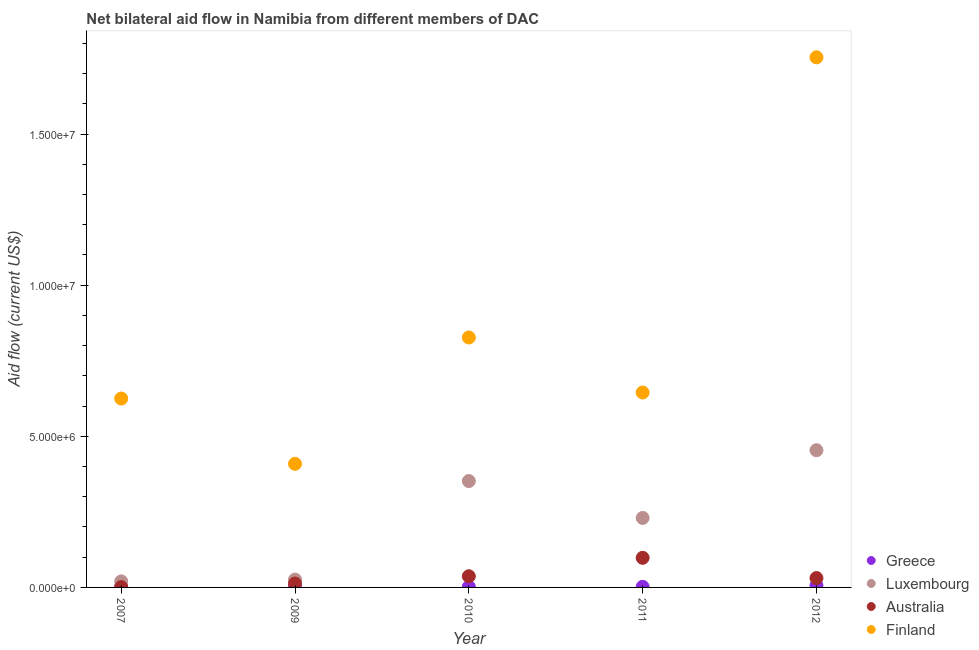How many different coloured dotlines are there?
Offer a terse response. 4. What is the amount of aid given by australia in 2009?
Provide a short and direct response. 1.30e+05. Across all years, what is the maximum amount of aid given by luxembourg?
Your answer should be compact. 4.54e+06. Across all years, what is the minimum amount of aid given by finland?
Your answer should be very brief. 4.09e+06. What is the total amount of aid given by greece in the graph?
Your answer should be compact. 1.30e+05. What is the difference between the amount of aid given by greece in 2010 and that in 2012?
Your answer should be compact. -4.00e+04. What is the difference between the amount of aid given by greece in 2010 and the amount of aid given by luxembourg in 2009?
Make the answer very short. -2.40e+05. What is the average amount of aid given by greece per year?
Provide a short and direct response. 2.60e+04. In the year 2007, what is the difference between the amount of aid given by australia and amount of aid given by finland?
Your response must be concise. -6.24e+06. In how many years, is the amount of aid given by greece greater than 7000000 US$?
Ensure brevity in your answer.  0. What is the ratio of the amount of aid given by australia in 2007 to that in 2012?
Your response must be concise. 0.03. Is the difference between the amount of aid given by greece in 2010 and 2012 greater than the difference between the amount of aid given by australia in 2010 and 2012?
Ensure brevity in your answer.  No. What is the difference between the highest and the lowest amount of aid given by finland?
Give a very brief answer. 1.34e+07. Is the sum of the amount of aid given by luxembourg in 2007 and 2009 greater than the maximum amount of aid given by finland across all years?
Keep it short and to the point. No. Is it the case that in every year, the sum of the amount of aid given by greece and amount of aid given by luxembourg is greater than the sum of amount of aid given by finland and amount of aid given by australia?
Give a very brief answer. No. Is the amount of aid given by australia strictly greater than the amount of aid given by finland over the years?
Give a very brief answer. No. How many dotlines are there?
Ensure brevity in your answer.  4. How many years are there in the graph?
Your response must be concise. 5. How are the legend labels stacked?
Provide a short and direct response. Vertical. What is the title of the graph?
Offer a very short reply. Net bilateral aid flow in Namibia from different members of DAC. Does "Tertiary schools" appear as one of the legend labels in the graph?
Your response must be concise. No. What is the label or title of the X-axis?
Your response must be concise. Year. What is the Aid flow (current US$) of Greece in 2007?
Your response must be concise. 10000. What is the Aid flow (current US$) in Australia in 2007?
Make the answer very short. 10000. What is the Aid flow (current US$) in Finland in 2007?
Your response must be concise. 6.25e+06. What is the Aid flow (current US$) of Luxembourg in 2009?
Give a very brief answer. 2.60e+05. What is the Aid flow (current US$) in Finland in 2009?
Give a very brief answer. 4.09e+06. What is the Aid flow (current US$) in Greece in 2010?
Offer a very short reply. 2.00e+04. What is the Aid flow (current US$) in Luxembourg in 2010?
Give a very brief answer. 3.52e+06. What is the Aid flow (current US$) in Finland in 2010?
Your response must be concise. 8.27e+06. What is the Aid flow (current US$) in Luxembourg in 2011?
Provide a succinct answer. 2.30e+06. What is the Aid flow (current US$) in Australia in 2011?
Your response must be concise. 9.80e+05. What is the Aid flow (current US$) of Finland in 2011?
Give a very brief answer. 6.45e+06. What is the Aid flow (current US$) in Luxembourg in 2012?
Your answer should be very brief. 4.54e+06. What is the Aid flow (current US$) of Finland in 2012?
Provide a short and direct response. 1.75e+07. Across all years, what is the maximum Aid flow (current US$) of Greece?
Provide a succinct answer. 6.00e+04. Across all years, what is the maximum Aid flow (current US$) in Luxembourg?
Give a very brief answer. 4.54e+06. Across all years, what is the maximum Aid flow (current US$) of Australia?
Offer a very short reply. 9.80e+05. Across all years, what is the maximum Aid flow (current US$) of Finland?
Give a very brief answer. 1.75e+07. Across all years, what is the minimum Aid flow (current US$) in Greece?
Make the answer very short. 10000. Across all years, what is the minimum Aid flow (current US$) in Luxembourg?
Ensure brevity in your answer.  2.00e+05. Across all years, what is the minimum Aid flow (current US$) in Finland?
Make the answer very short. 4.09e+06. What is the total Aid flow (current US$) in Greece in the graph?
Give a very brief answer. 1.30e+05. What is the total Aid flow (current US$) of Luxembourg in the graph?
Provide a short and direct response. 1.08e+07. What is the total Aid flow (current US$) of Australia in the graph?
Offer a very short reply. 1.80e+06. What is the total Aid flow (current US$) in Finland in the graph?
Your answer should be very brief. 4.26e+07. What is the difference between the Aid flow (current US$) in Greece in 2007 and that in 2009?
Offer a very short reply. -10000. What is the difference between the Aid flow (current US$) in Luxembourg in 2007 and that in 2009?
Provide a short and direct response. -6.00e+04. What is the difference between the Aid flow (current US$) in Australia in 2007 and that in 2009?
Your response must be concise. -1.20e+05. What is the difference between the Aid flow (current US$) of Finland in 2007 and that in 2009?
Ensure brevity in your answer.  2.16e+06. What is the difference between the Aid flow (current US$) of Greece in 2007 and that in 2010?
Provide a succinct answer. -10000. What is the difference between the Aid flow (current US$) in Luxembourg in 2007 and that in 2010?
Your answer should be compact. -3.32e+06. What is the difference between the Aid flow (current US$) in Australia in 2007 and that in 2010?
Provide a short and direct response. -3.60e+05. What is the difference between the Aid flow (current US$) in Finland in 2007 and that in 2010?
Provide a succinct answer. -2.02e+06. What is the difference between the Aid flow (current US$) of Greece in 2007 and that in 2011?
Your response must be concise. -10000. What is the difference between the Aid flow (current US$) in Luxembourg in 2007 and that in 2011?
Your answer should be compact. -2.10e+06. What is the difference between the Aid flow (current US$) of Australia in 2007 and that in 2011?
Your answer should be compact. -9.70e+05. What is the difference between the Aid flow (current US$) of Luxembourg in 2007 and that in 2012?
Your response must be concise. -4.34e+06. What is the difference between the Aid flow (current US$) of Australia in 2007 and that in 2012?
Give a very brief answer. -3.00e+05. What is the difference between the Aid flow (current US$) of Finland in 2007 and that in 2012?
Make the answer very short. -1.13e+07. What is the difference between the Aid flow (current US$) of Greece in 2009 and that in 2010?
Your answer should be very brief. 0. What is the difference between the Aid flow (current US$) of Luxembourg in 2009 and that in 2010?
Keep it short and to the point. -3.26e+06. What is the difference between the Aid flow (current US$) of Australia in 2009 and that in 2010?
Your response must be concise. -2.40e+05. What is the difference between the Aid flow (current US$) of Finland in 2009 and that in 2010?
Keep it short and to the point. -4.18e+06. What is the difference between the Aid flow (current US$) in Greece in 2009 and that in 2011?
Ensure brevity in your answer.  0. What is the difference between the Aid flow (current US$) in Luxembourg in 2009 and that in 2011?
Make the answer very short. -2.04e+06. What is the difference between the Aid flow (current US$) in Australia in 2009 and that in 2011?
Ensure brevity in your answer.  -8.50e+05. What is the difference between the Aid flow (current US$) in Finland in 2009 and that in 2011?
Offer a terse response. -2.36e+06. What is the difference between the Aid flow (current US$) of Luxembourg in 2009 and that in 2012?
Your answer should be very brief. -4.28e+06. What is the difference between the Aid flow (current US$) in Australia in 2009 and that in 2012?
Provide a short and direct response. -1.80e+05. What is the difference between the Aid flow (current US$) of Finland in 2009 and that in 2012?
Offer a very short reply. -1.34e+07. What is the difference between the Aid flow (current US$) of Greece in 2010 and that in 2011?
Your answer should be compact. 0. What is the difference between the Aid flow (current US$) in Luxembourg in 2010 and that in 2011?
Make the answer very short. 1.22e+06. What is the difference between the Aid flow (current US$) in Australia in 2010 and that in 2011?
Make the answer very short. -6.10e+05. What is the difference between the Aid flow (current US$) of Finland in 2010 and that in 2011?
Your response must be concise. 1.82e+06. What is the difference between the Aid flow (current US$) in Luxembourg in 2010 and that in 2012?
Offer a terse response. -1.02e+06. What is the difference between the Aid flow (current US$) in Finland in 2010 and that in 2012?
Your answer should be very brief. -9.27e+06. What is the difference between the Aid flow (current US$) in Luxembourg in 2011 and that in 2012?
Provide a succinct answer. -2.24e+06. What is the difference between the Aid flow (current US$) of Australia in 2011 and that in 2012?
Your answer should be very brief. 6.70e+05. What is the difference between the Aid flow (current US$) of Finland in 2011 and that in 2012?
Keep it short and to the point. -1.11e+07. What is the difference between the Aid flow (current US$) in Greece in 2007 and the Aid flow (current US$) in Australia in 2009?
Provide a succinct answer. -1.20e+05. What is the difference between the Aid flow (current US$) in Greece in 2007 and the Aid flow (current US$) in Finland in 2009?
Provide a succinct answer. -4.08e+06. What is the difference between the Aid flow (current US$) in Luxembourg in 2007 and the Aid flow (current US$) in Australia in 2009?
Your answer should be compact. 7.00e+04. What is the difference between the Aid flow (current US$) in Luxembourg in 2007 and the Aid flow (current US$) in Finland in 2009?
Ensure brevity in your answer.  -3.89e+06. What is the difference between the Aid flow (current US$) in Australia in 2007 and the Aid flow (current US$) in Finland in 2009?
Offer a terse response. -4.08e+06. What is the difference between the Aid flow (current US$) of Greece in 2007 and the Aid flow (current US$) of Luxembourg in 2010?
Provide a short and direct response. -3.51e+06. What is the difference between the Aid flow (current US$) of Greece in 2007 and the Aid flow (current US$) of Australia in 2010?
Ensure brevity in your answer.  -3.60e+05. What is the difference between the Aid flow (current US$) of Greece in 2007 and the Aid flow (current US$) of Finland in 2010?
Provide a short and direct response. -8.26e+06. What is the difference between the Aid flow (current US$) of Luxembourg in 2007 and the Aid flow (current US$) of Australia in 2010?
Provide a short and direct response. -1.70e+05. What is the difference between the Aid flow (current US$) of Luxembourg in 2007 and the Aid flow (current US$) of Finland in 2010?
Make the answer very short. -8.07e+06. What is the difference between the Aid flow (current US$) in Australia in 2007 and the Aid flow (current US$) in Finland in 2010?
Your answer should be compact. -8.26e+06. What is the difference between the Aid flow (current US$) in Greece in 2007 and the Aid flow (current US$) in Luxembourg in 2011?
Your answer should be very brief. -2.29e+06. What is the difference between the Aid flow (current US$) in Greece in 2007 and the Aid flow (current US$) in Australia in 2011?
Your response must be concise. -9.70e+05. What is the difference between the Aid flow (current US$) of Greece in 2007 and the Aid flow (current US$) of Finland in 2011?
Your answer should be very brief. -6.44e+06. What is the difference between the Aid flow (current US$) in Luxembourg in 2007 and the Aid flow (current US$) in Australia in 2011?
Provide a succinct answer. -7.80e+05. What is the difference between the Aid flow (current US$) in Luxembourg in 2007 and the Aid flow (current US$) in Finland in 2011?
Provide a short and direct response. -6.25e+06. What is the difference between the Aid flow (current US$) of Australia in 2007 and the Aid flow (current US$) of Finland in 2011?
Offer a terse response. -6.44e+06. What is the difference between the Aid flow (current US$) in Greece in 2007 and the Aid flow (current US$) in Luxembourg in 2012?
Your answer should be very brief. -4.53e+06. What is the difference between the Aid flow (current US$) of Greece in 2007 and the Aid flow (current US$) of Australia in 2012?
Offer a terse response. -3.00e+05. What is the difference between the Aid flow (current US$) of Greece in 2007 and the Aid flow (current US$) of Finland in 2012?
Offer a very short reply. -1.75e+07. What is the difference between the Aid flow (current US$) in Luxembourg in 2007 and the Aid flow (current US$) in Finland in 2012?
Provide a succinct answer. -1.73e+07. What is the difference between the Aid flow (current US$) of Australia in 2007 and the Aid flow (current US$) of Finland in 2012?
Your response must be concise. -1.75e+07. What is the difference between the Aid flow (current US$) in Greece in 2009 and the Aid flow (current US$) in Luxembourg in 2010?
Offer a terse response. -3.50e+06. What is the difference between the Aid flow (current US$) of Greece in 2009 and the Aid flow (current US$) of Australia in 2010?
Provide a short and direct response. -3.50e+05. What is the difference between the Aid flow (current US$) of Greece in 2009 and the Aid flow (current US$) of Finland in 2010?
Make the answer very short. -8.25e+06. What is the difference between the Aid flow (current US$) of Luxembourg in 2009 and the Aid flow (current US$) of Australia in 2010?
Offer a terse response. -1.10e+05. What is the difference between the Aid flow (current US$) in Luxembourg in 2009 and the Aid flow (current US$) in Finland in 2010?
Provide a succinct answer. -8.01e+06. What is the difference between the Aid flow (current US$) in Australia in 2009 and the Aid flow (current US$) in Finland in 2010?
Make the answer very short. -8.14e+06. What is the difference between the Aid flow (current US$) in Greece in 2009 and the Aid flow (current US$) in Luxembourg in 2011?
Offer a very short reply. -2.28e+06. What is the difference between the Aid flow (current US$) of Greece in 2009 and the Aid flow (current US$) of Australia in 2011?
Make the answer very short. -9.60e+05. What is the difference between the Aid flow (current US$) of Greece in 2009 and the Aid flow (current US$) of Finland in 2011?
Your response must be concise. -6.43e+06. What is the difference between the Aid flow (current US$) in Luxembourg in 2009 and the Aid flow (current US$) in Australia in 2011?
Keep it short and to the point. -7.20e+05. What is the difference between the Aid flow (current US$) of Luxembourg in 2009 and the Aid flow (current US$) of Finland in 2011?
Keep it short and to the point. -6.19e+06. What is the difference between the Aid flow (current US$) of Australia in 2009 and the Aid flow (current US$) of Finland in 2011?
Your answer should be compact. -6.32e+06. What is the difference between the Aid flow (current US$) of Greece in 2009 and the Aid flow (current US$) of Luxembourg in 2012?
Keep it short and to the point. -4.52e+06. What is the difference between the Aid flow (current US$) of Greece in 2009 and the Aid flow (current US$) of Australia in 2012?
Offer a very short reply. -2.90e+05. What is the difference between the Aid flow (current US$) in Greece in 2009 and the Aid flow (current US$) in Finland in 2012?
Offer a terse response. -1.75e+07. What is the difference between the Aid flow (current US$) in Luxembourg in 2009 and the Aid flow (current US$) in Australia in 2012?
Keep it short and to the point. -5.00e+04. What is the difference between the Aid flow (current US$) of Luxembourg in 2009 and the Aid flow (current US$) of Finland in 2012?
Ensure brevity in your answer.  -1.73e+07. What is the difference between the Aid flow (current US$) in Australia in 2009 and the Aid flow (current US$) in Finland in 2012?
Provide a short and direct response. -1.74e+07. What is the difference between the Aid flow (current US$) in Greece in 2010 and the Aid flow (current US$) in Luxembourg in 2011?
Your response must be concise. -2.28e+06. What is the difference between the Aid flow (current US$) of Greece in 2010 and the Aid flow (current US$) of Australia in 2011?
Provide a short and direct response. -9.60e+05. What is the difference between the Aid flow (current US$) in Greece in 2010 and the Aid flow (current US$) in Finland in 2011?
Provide a succinct answer. -6.43e+06. What is the difference between the Aid flow (current US$) in Luxembourg in 2010 and the Aid flow (current US$) in Australia in 2011?
Keep it short and to the point. 2.54e+06. What is the difference between the Aid flow (current US$) of Luxembourg in 2010 and the Aid flow (current US$) of Finland in 2011?
Offer a terse response. -2.93e+06. What is the difference between the Aid flow (current US$) in Australia in 2010 and the Aid flow (current US$) in Finland in 2011?
Give a very brief answer. -6.08e+06. What is the difference between the Aid flow (current US$) in Greece in 2010 and the Aid flow (current US$) in Luxembourg in 2012?
Keep it short and to the point. -4.52e+06. What is the difference between the Aid flow (current US$) of Greece in 2010 and the Aid flow (current US$) of Finland in 2012?
Provide a short and direct response. -1.75e+07. What is the difference between the Aid flow (current US$) in Luxembourg in 2010 and the Aid flow (current US$) in Australia in 2012?
Provide a short and direct response. 3.21e+06. What is the difference between the Aid flow (current US$) of Luxembourg in 2010 and the Aid flow (current US$) of Finland in 2012?
Your answer should be very brief. -1.40e+07. What is the difference between the Aid flow (current US$) of Australia in 2010 and the Aid flow (current US$) of Finland in 2012?
Offer a very short reply. -1.72e+07. What is the difference between the Aid flow (current US$) of Greece in 2011 and the Aid flow (current US$) of Luxembourg in 2012?
Ensure brevity in your answer.  -4.52e+06. What is the difference between the Aid flow (current US$) in Greece in 2011 and the Aid flow (current US$) in Australia in 2012?
Offer a terse response. -2.90e+05. What is the difference between the Aid flow (current US$) of Greece in 2011 and the Aid flow (current US$) of Finland in 2012?
Provide a succinct answer. -1.75e+07. What is the difference between the Aid flow (current US$) in Luxembourg in 2011 and the Aid flow (current US$) in Australia in 2012?
Ensure brevity in your answer.  1.99e+06. What is the difference between the Aid flow (current US$) in Luxembourg in 2011 and the Aid flow (current US$) in Finland in 2012?
Provide a short and direct response. -1.52e+07. What is the difference between the Aid flow (current US$) in Australia in 2011 and the Aid flow (current US$) in Finland in 2012?
Give a very brief answer. -1.66e+07. What is the average Aid flow (current US$) in Greece per year?
Your answer should be compact. 2.60e+04. What is the average Aid flow (current US$) in Luxembourg per year?
Give a very brief answer. 2.16e+06. What is the average Aid flow (current US$) in Australia per year?
Offer a very short reply. 3.60e+05. What is the average Aid flow (current US$) in Finland per year?
Provide a succinct answer. 8.52e+06. In the year 2007, what is the difference between the Aid flow (current US$) in Greece and Aid flow (current US$) in Finland?
Offer a terse response. -6.24e+06. In the year 2007, what is the difference between the Aid flow (current US$) of Luxembourg and Aid flow (current US$) of Finland?
Your answer should be very brief. -6.05e+06. In the year 2007, what is the difference between the Aid flow (current US$) of Australia and Aid flow (current US$) of Finland?
Provide a succinct answer. -6.24e+06. In the year 2009, what is the difference between the Aid flow (current US$) of Greece and Aid flow (current US$) of Luxembourg?
Ensure brevity in your answer.  -2.40e+05. In the year 2009, what is the difference between the Aid flow (current US$) in Greece and Aid flow (current US$) in Finland?
Your answer should be compact. -4.07e+06. In the year 2009, what is the difference between the Aid flow (current US$) of Luxembourg and Aid flow (current US$) of Australia?
Your answer should be very brief. 1.30e+05. In the year 2009, what is the difference between the Aid flow (current US$) in Luxembourg and Aid flow (current US$) in Finland?
Offer a very short reply. -3.83e+06. In the year 2009, what is the difference between the Aid flow (current US$) of Australia and Aid flow (current US$) of Finland?
Your answer should be very brief. -3.96e+06. In the year 2010, what is the difference between the Aid flow (current US$) in Greece and Aid flow (current US$) in Luxembourg?
Give a very brief answer. -3.50e+06. In the year 2010, what is the difference between the Aid flow (current US$) in Greece and Aid flow (current US$) in Australia?
Your answer should be very brief. -3.50e+05. In the year 2010, what is the difference between the Aid flow (current US$) in Greece and Aid flow (current US$) in Finland?
Your response must be concise. -8.25e+06. In the year 2010, what is the difference between the Aid flow (current US$) of Luxembourg and Aid flow (current US$) of Australia?
Your answer should be compact. 3.15e+06. In the year 2010, what is the difference between the Aid flow (current US$) in Luxembourg and Aid flow (current US$) in Finland?
Offer a terse response. -4.75e+06. In the year 2010, what is the difference between the Aid flow (current US$) of Australia and Aid flow (current US$) of Finland?
Offer a very short reply. -7.90e+06. In the year 2011, what is the difference between the Aid flow (current US$) of Greece and Aid flow (current US$) of Luxembourg?
Keep it short and to the point. -2.28e+06. In the year 2011, what is the difference between the Aid flow (current US$) of Greece and Aid flow (current US$) of Australia?
Give a very brief answer. -9.60e+05. In the year 2011, what is the difference between the Aid flow (current US$) in Greece and Aid flow (current US$) in Finland?
Your answer should be very brief. -6.43e+06. In the year 2011, what is the difference between the Aid flow (current US$) in Luxembourg and Aid flow (current US$) in Australia?
Provide a short and direct response. 1.32e+06. In the year 2011, what is the difference between the Aid flow (current US$) in Luxembourg and Aid flow (current US$) in Finland?
Provide a short and direct response. -4.15e+06. In the year 2011, what is the difference between the Aid flow (current US$) in Australia and Aid flow (current US$) in Finland?
Your response must be concise. -5.47e+06. In the year 2012, what is the difference between the Aid flow (current US$) in Greece and Aid flow (current US$) in Luxembourg?
Make the answer very short. -4.48e+06. In the year 2012, what is the difference between the Aid flow (current US$) of Greece and Aid flow (current US$) of Finland?
Provide a short and direct response. -1.75e+07. In the year 2012, what is the difference between the Aid flow (current US$) of Luxembourg and Aid flow (current US$) of Australia?
Your response must be concise. 4.23e+06. In the year 2012, what is the difference between the Aid flow (current US$) of Luxembourg and Aid flow (current US$) of Finland?
Your answer should be very brief. -1.30e+07. In the year 2012, what is the difference between the Aid flow (current US$) of Australia and Aid flow (current US$) of Finland?
Offer a terse response. -1.72e+07. What is the ratio of the Aid flow (current US$) of Luxembourg in 2007 to that in 2009?
Make the answer very short. 0.77. What is the ratio of the Aid flow (current US$) in Australia in 2007 to that in 2009?
Ensure brevity in your answer.  0.08. What is the ratio of the Aid flow (current US$) of Finland in 2007 to that in 2009?
Provide a succinct answer. 1.53. What is the ratio of the Aid flow (current US$) of Luxembourg in 2007 to that in 2010?
Offer a terse response. 0.06. What is the ratio of the Aid flow (current US$) of Australia in 2007 to that in 2010?
Your response must be concise. 0.03. What is the ratio of the Aid flow (current US$) in Finland in 2007 to that in 2010?
Ensure brevity in your answer.  0.76. What is the ratio of the Aid flow (current US$) in Luxembourg in 2007 to that in 2011?
Give a very brief answer. 0.09. What is the ratio of the Aid flow (current US$) of Australia in 2007 to that in 2011?
Provide a short and direct response. 0.01. What is the ratio of the Aid flow (current US$) in Greece in 2007 to that in 2012?
Keep it short and to the point. 0.17. What is the ratio of the Aid flow (current US$) in Luxembourg in 2007 to that in 2012?
Give a very brief answer. 0.04. What is the ratio of the Aid flow (current US$) of Australia in 2007 to that in 2012?
Provide a succinct answer. 0.03. What is the ratio of the Aid flow (current US$) of Finland in 2007 to that in 2012?
Provide a short and direct response. 0.36. What is the ratio of the Aid flow (current US$) in Luxembourg in 2009 to that in 2010?
Ensure brevity in your answer.  0.07. What is the ratio of the Aid flow (current US$) of Australia in 2009 to that in 2010?
Your response must be concise. 0.35. What is the ratio of the Aid flow (current US$) in Finland in 2009 to that in 2010?
Give a very brief answer. 0.49. What is the ratio of the Aid flow (current US$) of Luxembourg in 2009 to that in 2011?
Your answer should be very brief. 0.11. What is the ratio of the Aid flow (current US$) of Australia in 2009 to that in 2011?
Keep it short and to the point. 0.13. What is the ratio of the Aid flow (current US$) in Finland in 2009 to that in 2011?
Your answer should be compact. 0.63. What is the ratio of the Aid flow (current US$) of Greece in 2009 to that in 2012?
Your answer should be compact. 0.33. What is the ratio of the Aid flow (current US$) in Luxembourg in 2009 to that in 2012?
Offer a terse response. 0.06. What is the ratio of the Aid flow (current US$) of Australia in 2009 to that in 2012?
Make the answer very short. 0.42. What is the ratio of the Aid flow (current US$) in Finland in 2009 to that in 2012?
Ensure brevity in your answer.  0.23. What is the ratio of the Aid flow (current US$) in Greece in 2010 to that in 2011?
Offer a terse response. 1. What is the ratio of the Aid flow (current US$) in Luxembourg in 2010 to that in 2011?
Offer a terse response. 1.53. What is the ratio of the Aid flow (current US$) in Australia in 2010 to that in 2011?
Offer a very short reply. 0.38. What is the ratio of the Aid flow (current US$) of Finland in 2010 to that in 2011?
Provide a succinct answer. 1.28. What is the ratio of the Aid flow (current US$) of Greece in 2010 to that in 2012?
Keep it short and to the point. 0.33. What is the ratio of the Aid flow (current US$) of Luxembourg in 2010 to that in 2012?
Your answer should be compact. 0.78. What is the ratio of the Aid flow (current US$) in Australia in 2010 to that in 2012?
Provide a short and direct response. 1.19. What is the ratio of the Aid flow (current US$) of Finland in 2010 to that in 2012?
Offer a very short reply. 0.47. What is the ratio of the Aid flow (current US$) in Luxembourg in 2011 to that in 2012?
Offer a terse response. 0.51. What is the ratio of the Aid flow (current US$) in Australia in 2011 to that in 2012?
Provide a succinct answer. 3.16. What is the ratio of the Aid flow (current US$) of Finland in 2011 to that in 2012?
Provide a succinct answer. 0.37. What is the difference between the highest and the second highest Aid flow (current US$) of Greece?
Your response must be concise. 4.00e+04. What is the difference between the highest and the second highest Aid flow (current US$) in Luxembourg?
Make the answer very short. 1.02e+06. What is the difference between the highest and the second highest Aid flow (current US$) in Finland?
Your response must be concise. 9.27e+06. What is the difference between the highest and the lowest Aid flow (current US$) in Greece?
Offer a terse response. 5.00e+04. What is the difference between the highest and the lowest Aid flow (current US$) in Luxembourg?
Your answer should be very brief. 4.34e+06. What is the difference between the highest and the lowest Aid flow (current US$) of Australia?
Your answer should be compact. 9.70e+05. What is the difference between the highest and the lowest Aid flow (current US$) of Finland?
Your answer should be very brief. 1.34e+07. 